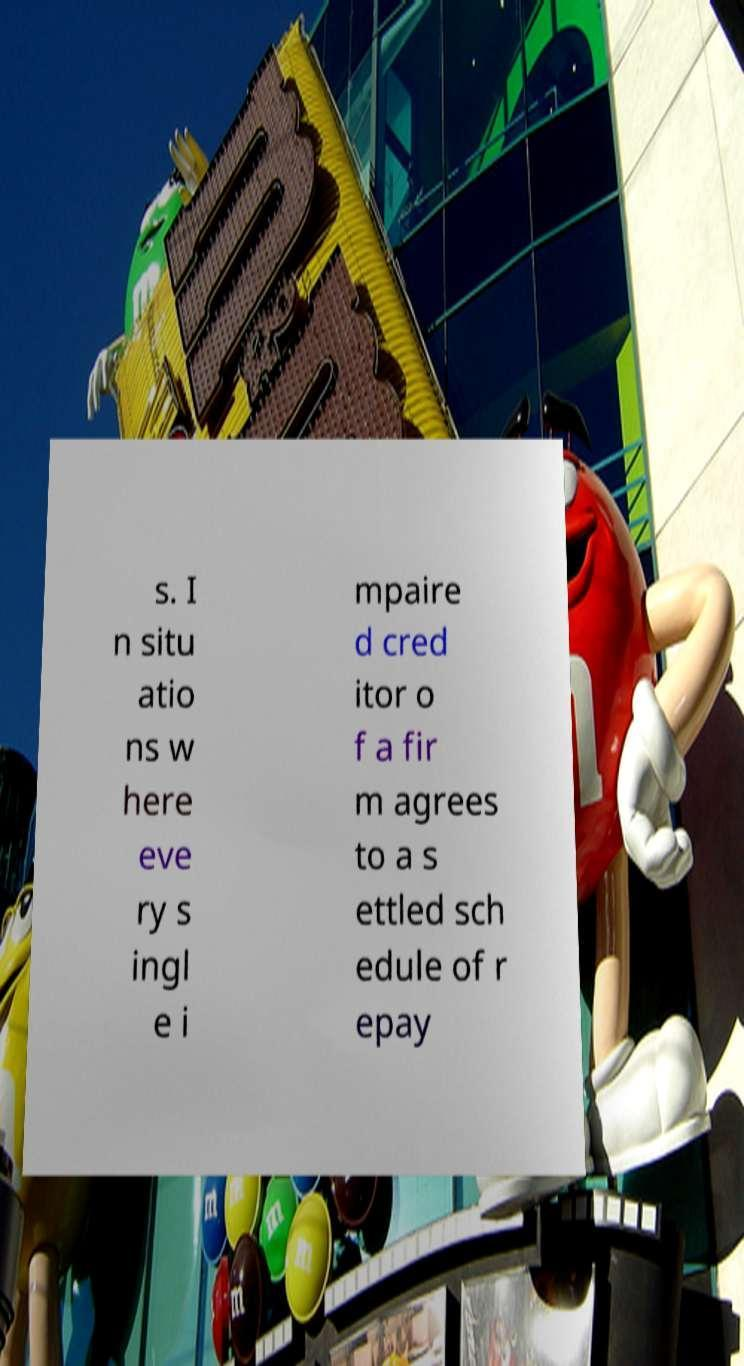There's text embedded in this image that I need extracted. Can you transcribe it verbatim? s. I n situ atio ns w here eve ry s ingl e i mpaire d cred itor o f a fir m agrees to a s ettled sch edule of r epay 